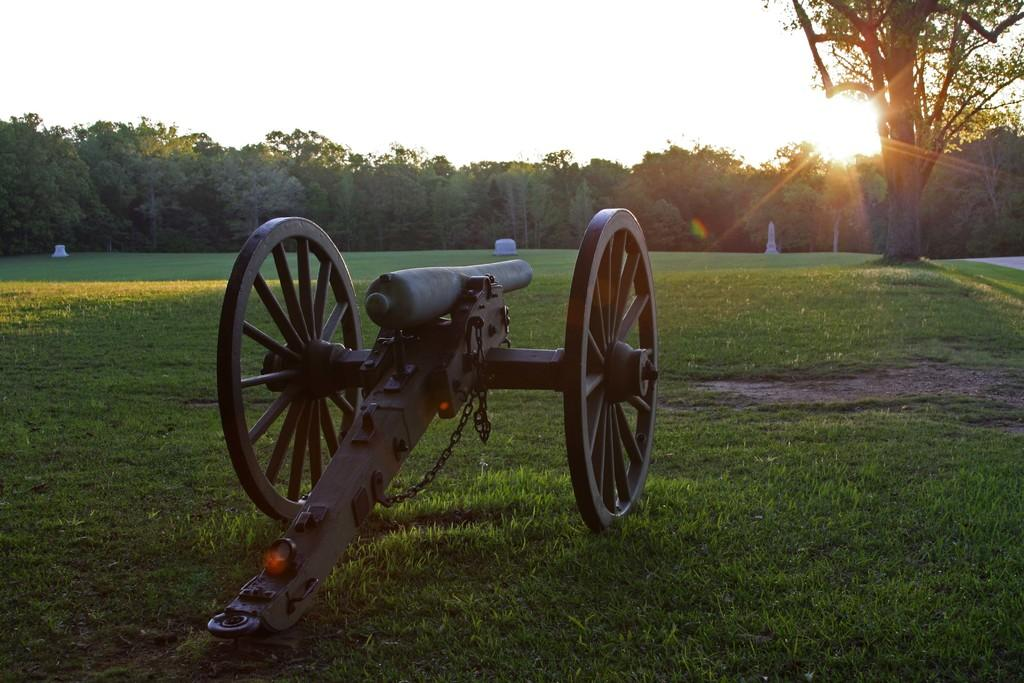What is the main object in the image? There is a cannon gun in the image. Where is the cannon gun located? The cannon gun is on the surface of the grass. What can be seen in the background of the image? There are trees visible in the background of the image. What type of paste is being used to create the scarecrow in the image? There is no scarecrow or paste present in the image; it features a cannon gun on the grass with trees in the background. 